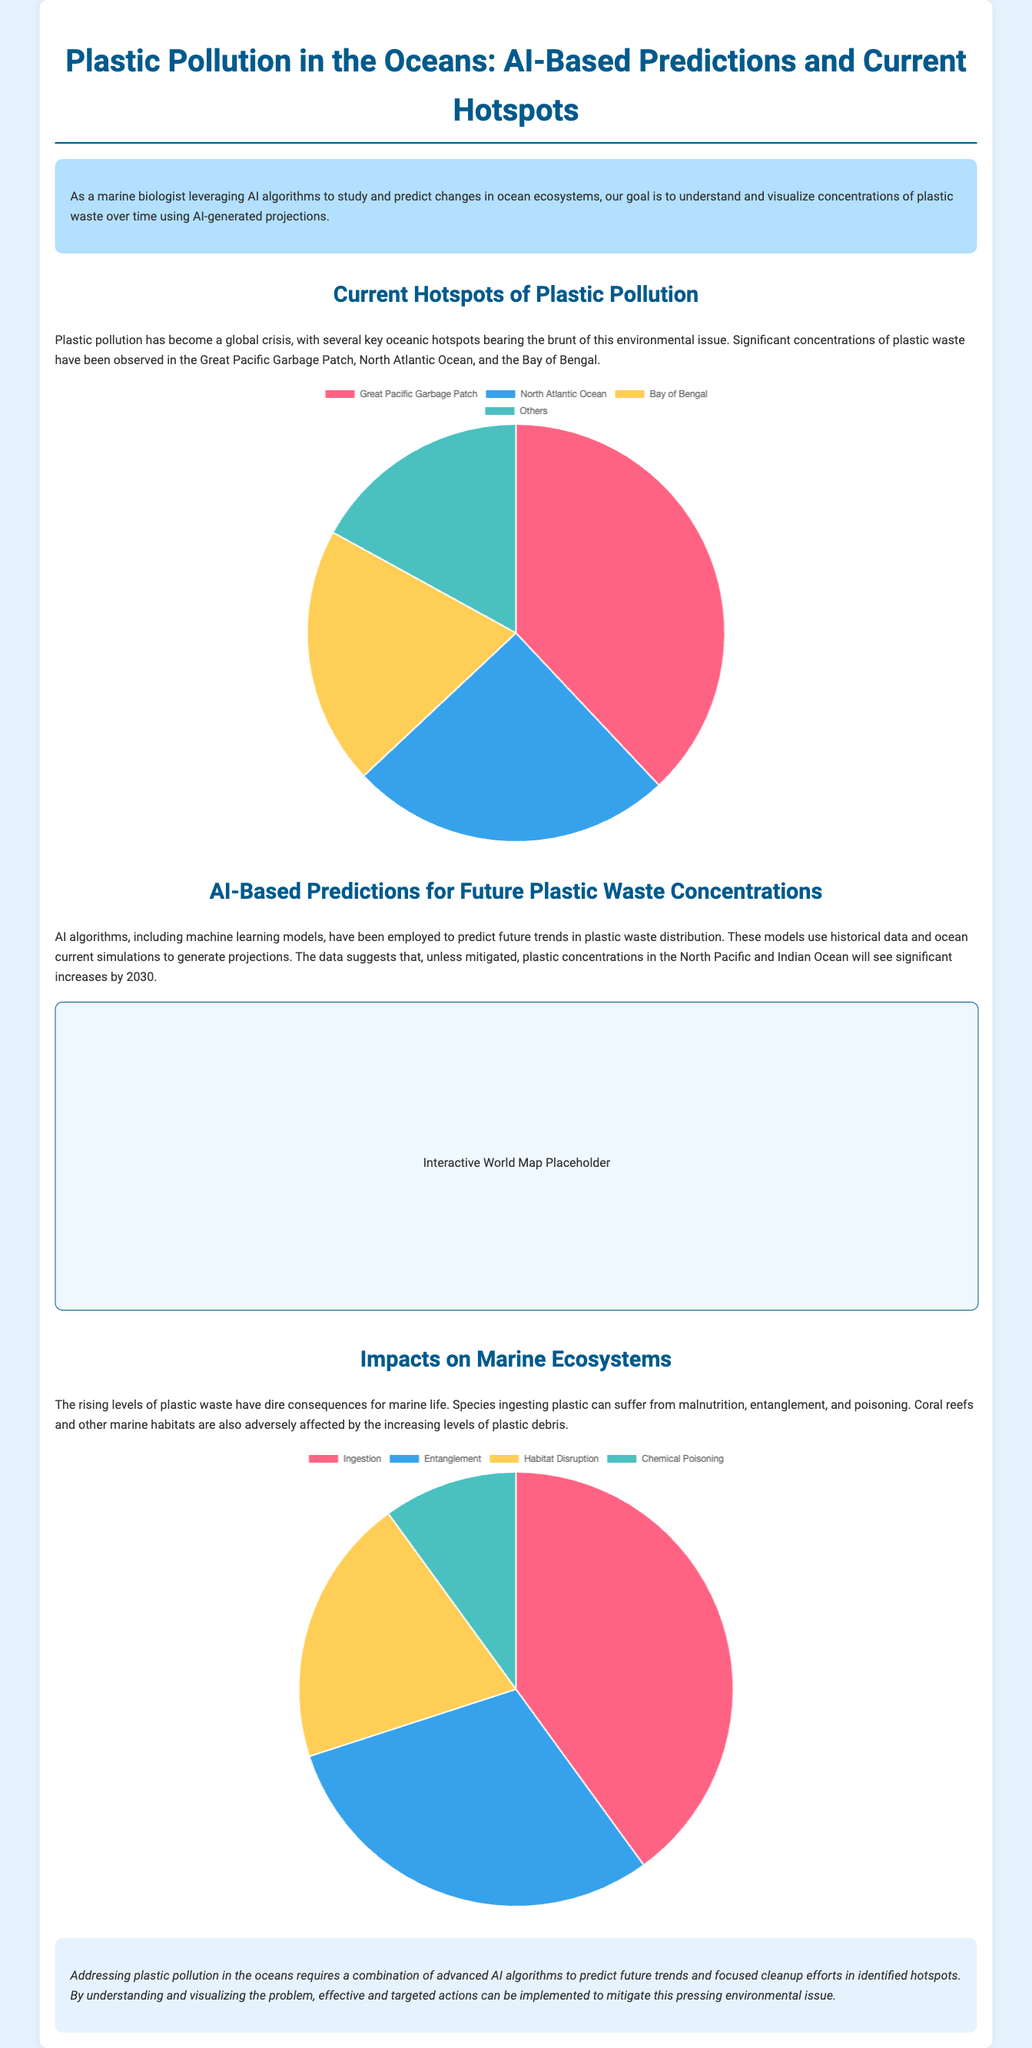What is the title of the infographic? The title is provided in the document's header, summarizing the focus on plastic pollution and AI predictions.
Answer: Plastic Pollution in the Oceans: AI-Based Predictions and Current Hotspots What is the percentage of plastic waste in the Great Pacific Garbage Patch? The percentage is specified in the pie chart data section depicting the current hotspots of plastic pollution.
Answer: 38 Which three areas are identified as current hotspots of plastic pollution? The document lists these significant regions where plastic concentrations are high.
Answer: Great Pacific Garbage Patch, North Atlantic Ocean, Bay of Bengal What are the four impacts of plastic pollution on marine ecosystems? The document specifies these impacts in the impact chart section.
Answer: Ingestion, Entanglement, Habitat Disruption, Chemical Poisoning What year does the AI projection forecast significant increases in plastic concentrations? The document mentions this projected year when discussing future trends in plastic waste distribution.
Answer: 2030 Which chart type is used to represent the current hotspots of plastic pollution? The document indicates the visual representation method used for depicting hotspots.
Answer: Pie chart What new technology is being employed to predict future trends in plastic pollution? The document refers to the advanced techniques used for prediction in the ocean ecosystem context.
Answer: AI algorithms What is one major consequence of rising plastic levels mentioned in the document? The document highlights a critical issue related to marine life suffering due to plastic pollution.
Answer: Malnutrition 